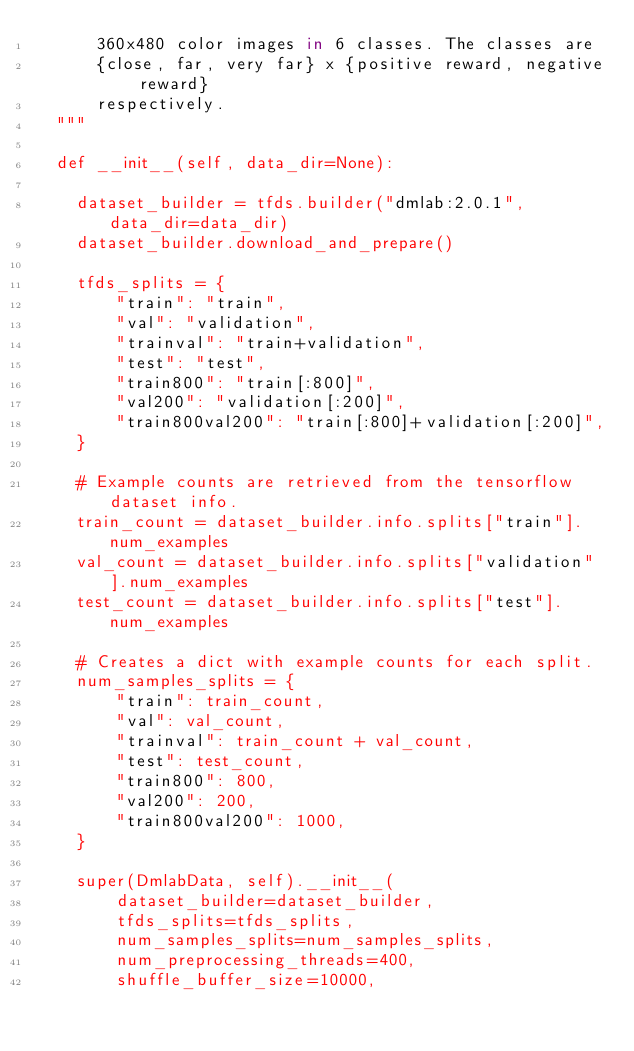Convert code to text. <code><loc_0><loc_0><loc_500><loc_500><_Python_>      360x480 color images in 6 classes. The classes are
      {close, far, very far} x {positive reward, negative reward}
      respectively.
  """

  def __init__(self, data_dir=None):

    dataset_builder = tfds.builder("dmlab:2.0.1", data_dir=data_dir)
    dataset_builder.download_and_prepare()

    tfds_splits = {
        "train": "train",
        "val": "validation",
        "trainval": "train+validation",
        "test": "test",
        "train800": "train[:800]",
        "val200": "validation[:200]",
        "train800val200": "train[:800]+validation[:200]",
    }

    # Example counts are retrieved from the tensorflow dataset info.
    train_count = dataset_builder.info.splits["train"].num_examples
    val_count = dataset_builder.info.splits["validation"].num_examples
    test_count = dataset_builder.info.splits["test"].num_examples

    # Creates a dict with example counts for each split.
    num_samples_splits = {
        "train": train_count,
        "val": val_count,
        "trainval": train_count + val_count,
        "test": test_count,
        "train800": 800,
        "val200": 200,
        "train800val200": 1000,
    }

    super(DmlabData, self).__init__(
        dataset_builder=dataset_builder,
        tfds_splits=tfds_splits,
        num_samples_splits=num_samples_splits,
        num_preprocessing_threads=400,
        shuffle_buffer_size=10000,</code> 